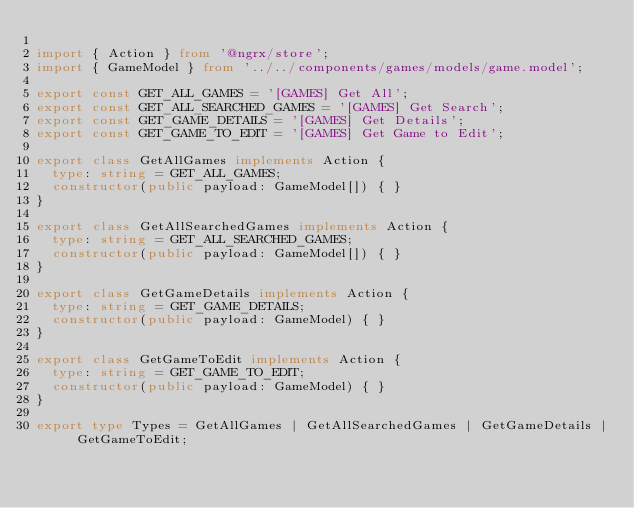<code> <loc_0><loc_0><loc_500><loc_500><_TypeScript_>
import { Action } from '@ngrx/store';
import { GameModel } from '../../components/games/models/game.model';

export const GET_ALL_GAMES = '[GAMES] Get All';
export const GET_ALL_SEARCHED_GAMES = '[GAMES] Get Search';
export const GET_GAME_DETAILS = '[GAMES] Get Details';
export const GET_GAME_TO_EDIT = '[GAMES] Get Game to Edit';

export class GetAllGames implements Action {
  type: string = GET_ALL_GAMES;
  constructor(public payload: GameModel[]) { }
}

export class GetAllSearchedGames implements Action {
  type: string = GET_ALL_SEARCHED_GAMES;
  constructor(public payload: GameModel[]) { }
}

export class GetGameDetails implements Action {
  type: string = GET_GAME_DETAILS;
  constructor(public payload: GameModel) { }
}

export class GetGameToEdit implements Action {
  type: string = GET_GAME_TO_EDIT;
  constructor(public payload: GameModel) { }
}

export type Types = GetAllGames | GetAllSearchedGames | GetGameDetails | GetGameToEdit;
</code> 